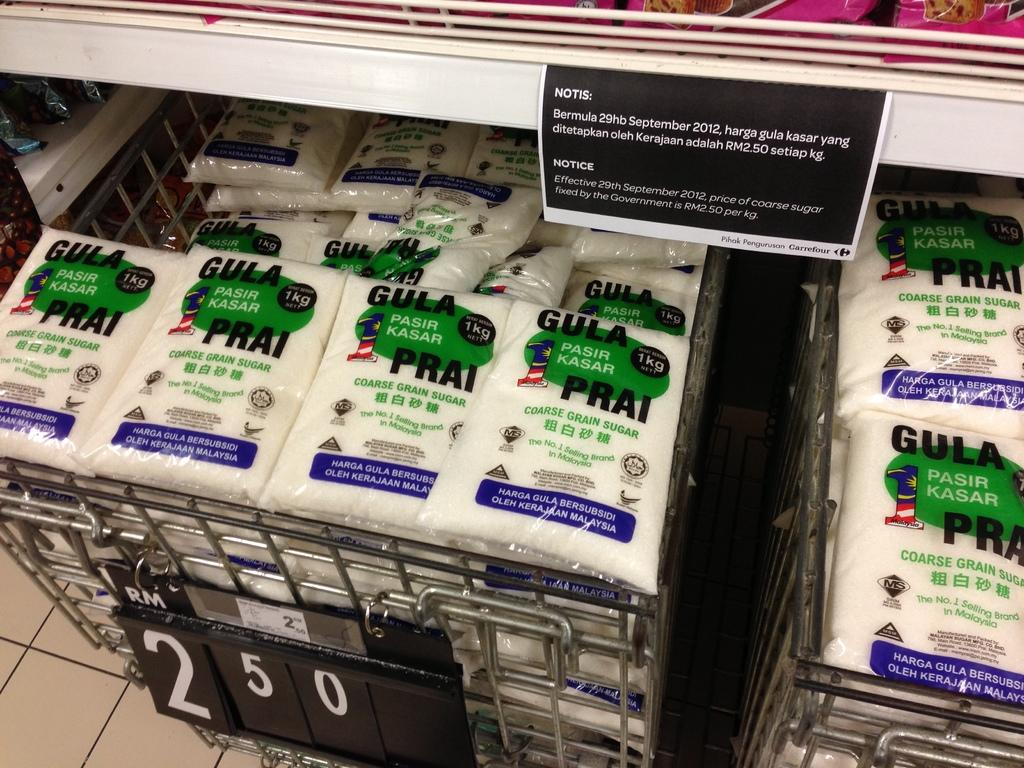<image>
Describe the image concisely. The cart is filled with Gula Prai bags. 